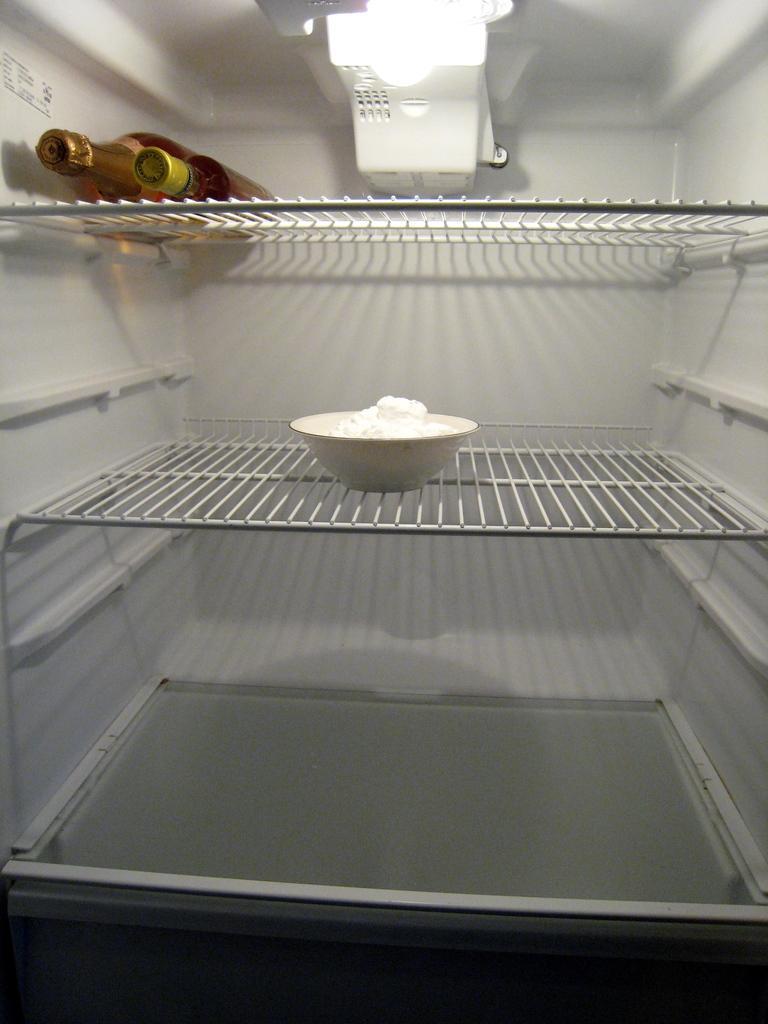Can you describe this image briefly? In this image there is a refrigerator with shelves and there is a light. There is a bowl with butter on the shelf and there are two bottles. 